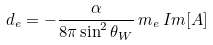Convert formula to latex. <formula><loc_0><loc_0><loc_500><loc_500>d _ { e } = - \frac { \alpha } { 8 \pi \sin ^ { 2 } \theta _ { W } } \, m _ { e } \, I m [ A ]</formula> 